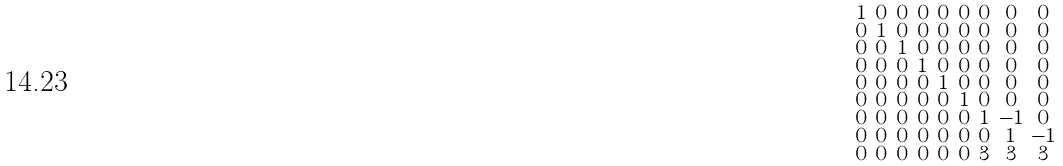<formula> <loc_0><loc_0><loc_500><loc_500>\begin{smallmatrix} 1 & 0 & 0 & 0 & 0 & 0 & 0 & 0 & 0 \\ 0 & 1 & 0 & 0 & 0 & 0 & 0 & 0 & 0 \\ 0 & 0 & 1 & 0 & 0 & 0 & 0 & 0 & 0 \\ 0 & 0 & 0 & 1 & 0 & 0 & 0 & 0 & 0 \\ 0 & 0 & 0 & 0 & 1 & 0 & 0 & 0 & 0 \\ 0 & 0 & 0 & 0 & 0 & 1 & 0 & 0 & 0 \\ 0 & 0 & 0 & 0 & 0 & 0 & 1 & - 1 & 0 \\ 0 & 0 & 0 & 0 & 0 & 0 & 0 & 1 & - 1 \\ 0 & 0 & 0 & 0 & 0 & 0 & 3 & 3 & 3 \end{smallmatrix}</formula> 